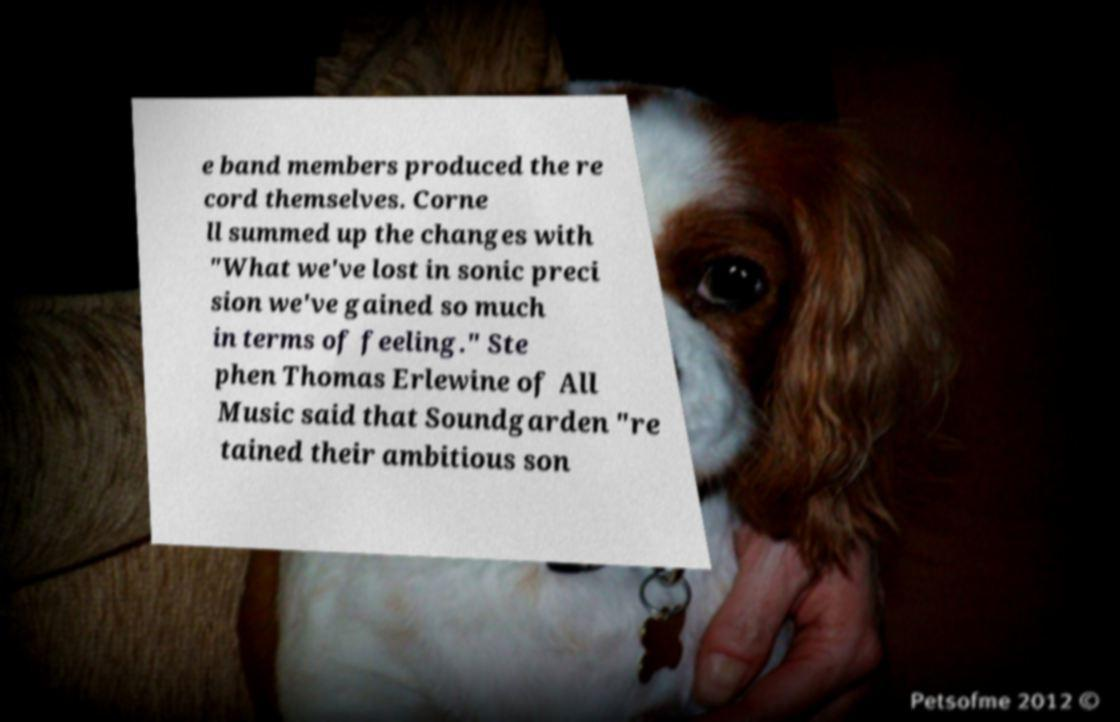I need the written content from this picture converted into text. Can you do that? e band members produced the re cord themselves. Corne ll summed up the changes with "What we've lost in sonic preci sion we've gained so much in terms of feeling." Ste phen Thomas Erlewine of All Music said that Soundgarden "re tained their ambitious son 